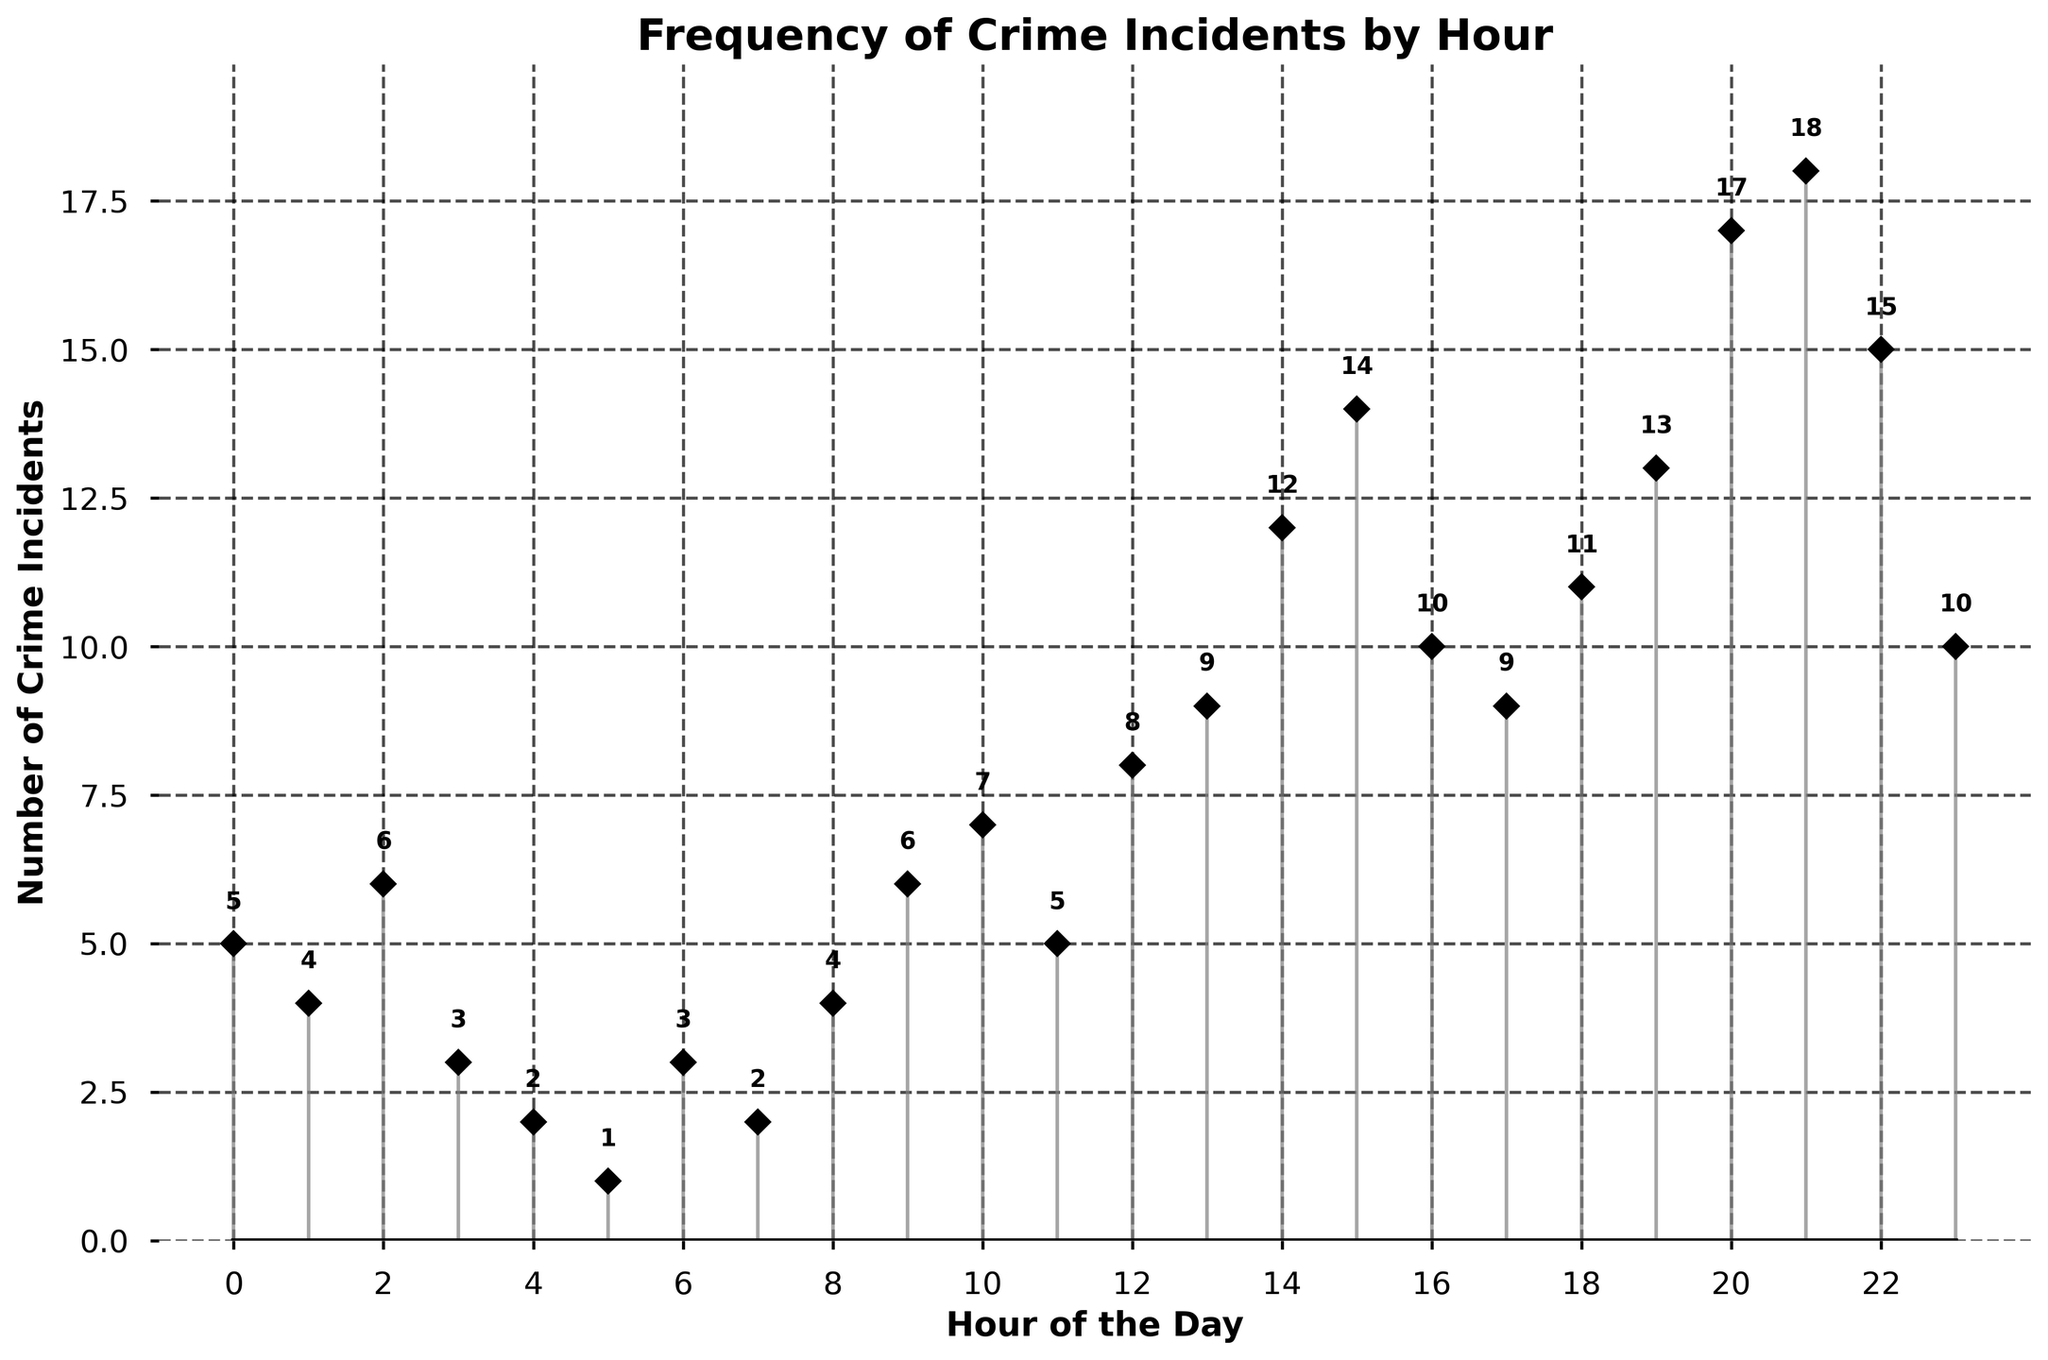What is the title of the figure? The title of the figure is displayed at the top in bold font, indicating the subject of the plot.
Answer: Frequency of Crime Incidents by Hour How many crime incidents were reported at 10 PM? Locate the 22nd hour (10 PM) on the x-axis and the corresponding data point on the y-axis.
Answer: 15 At what hour did the highest number of crime incidents occur? Look for the tallest stem on the plot and read the corresponding hour from the x-axis.
Answer: 21 What is the overall trend in the frequency of crime incidents throughout the day? Observing the plot, note the general pattern of the stems from 0 to 23 hours. The frequency of crime incidents tends to increase toward the late hours of the day.
Answer: Increases towards the evening and night How many hours of the day have crime incidents greater than or equal to 10? Identify and count the stems in the plot that reach at least the 10-mark on the y-axis.
Answer: 7 What is the difference in the number of crime incidents between 8 AM and 8 PM? Find the crime incidents at 8 AM (3) and 8 PM (13) and calculate the difference (13 - 4).
Answer: 9 Which hour has the lowest number of crime incidents? Identify the shortest stem on the plot and check the corresponding hour on the x-axis (in this case, the first data point at hour 5).
Answer: 5 Is there any hour with exactly 6 crime incidents reported? Look for any stems reaching the 6-mark on the y-axis and identify the hour (9th hour).
Answer: Yes Which hours have crime incidents less than or equal to 3? Look at the stems that are at or below the 3-mark on the y-axis and identify the corresponding hours.
Answer: 3, 4, 5, 6, 7 Are there more crime incidents in the afternoon (12 PM to 6 PM) or in the evening (6 PM to 12 AM)? Calculate the total incidents from 12 PM to 6 PM (59) and from 6 PM to 12 AM (84) by adding the values for each hour.
Answer: Evening (6 PM to 12 AM) Is the number of crime incidents consistent throughout the day? Examine the heights of the stems throughout the plot. The number of incidents varies considerably, peaking in the late evening.
Answer: No 